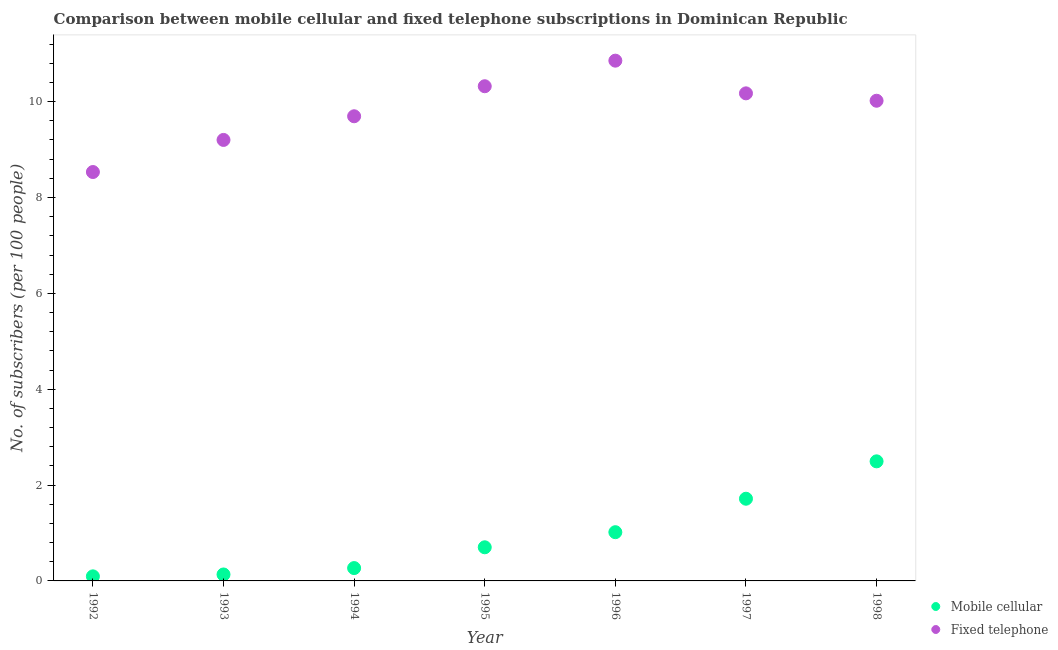Is the number of dotlines equal to the number of legend labels?
Your response must be concise. Yes. What is the number of mobile cellular subscribers in 1994?
Your answer should be very brief. 0.27. Across all years, what is the maximum number of fixed telephone subscribers?
Give a very brief answer. 10.85. Across all years, what is the minimum number of fixed telephone subscribers?
Offer a terse response. 8.53. What is the total number of fixed telephone subscribers in the graph?
Ensure brevity in your answer.  68.79. What is the difference between the number of mobile cellular subscribers in 1993 and that in 1996?
Ensure brevity in your answer.  -0.88. What is the difference between the number of mobile cellular subscribers in 1997 and the number of fixed telephone subscribers in 1994?
Provide a succinct answer. -7.98. What is the average number of fixed telephone subscribers per year?
Provide a short and direct response. 9.83. In the year 1996, what is the difference between the number of fixed telephone subscribers and number of mobile cellular subscribers?
Make the answer very short. 9.84. In how many years, is the number of fixed telephone subscribers greater than 7.6?
Make the answer very short. 7. What is the ratio of the number of mobile cellular subscribers in 1993 to that in 1994?
Your answer should be compact. 0.5. Is the difference between the number of fixed telephone subscribers in 1994 and 1995 greater than the difference between the number of mobile cellular subscribers in 1994 and 1995?
Your response must be concise. No. What is the difference between the highest and the second highest number of mobile cellular subscribers?
Provide a succinct answer. 0.78. What is the difference between the highest and the lowest number of mobile cellular subscribers?
Your answer should be very brief. 2.4. In how many years, is the number of mobile cellular subscribers greater than the average number of mobile cellular subscribers taken over all years?
Keep it short and to the point. 3. Is the sum of the number of fixed telephone subscribers in 1993 and 1997 greater than the maximum number of mobile cellular subscribers across all years?
Keep it short and to the point. Yes. Is the number of mobile cellular subscribers strictly less than the number of fixed telephone subscribers over the years?
Your answer should be very brief. Yes. How many dotlines are there?
Offer a very short reply. 2. How many years are there in the graph?
Your response must be concise. 7. What is the difference between two consecutive major ticks on the Y-axis?
Keep it short and to the point. 2. Are the values on the major ticks of Y-axis written in scientific E-notation?
Keep it short and to the point. No. Does the graph contain any zero values?
Offer a very short reply. No. Does the graph contain grids?
Ensure brevity in your answer.  No. What is the title of the graph?
Your response must be concise. Comparison between mobile cellular and fixed telephone subscriptions in Dominican Republic. Does "Domestic Liabilities" appear as one of the legend labels in the graph?
Give a very brief answer. No. What is the label or title of the X-axis?
Your answer should be compact. Year. What is the label or title of the Y-axis?
Offer a terse response. No. of subscribers (per 100 people). What is the No. of subscribers (per 100 people) in Mobile cellular in 1992?
Give a very brief answer. 0.1. What is the No. of subscribers (per 100 people) in Fixed telephone in 1992?
Your answer should be very brief. 8.53. What is the No. of subscribers (per 100 people) in Mobile cellular in 1993?
Offer a terse response. 0.13. What is the No. of subscribers (per 100 people) of Fixed telephone in 1993?
Offer a terse response. 9.2. What is the No. of subscribers (per 100 people) of Mobile cellular in 1994?
Offer a terse response. 0.27. What is the No. of subscribers (per 100 people) in Fixed telephone in 1994?
Your response must be concise. 9.69. What is the No. of subscribers (per 100 people) in Mobile cellular in 1995?
Your answer should be very brief. 0.7. What is the No. of subscribers (per 100 people) of Fixed telephone in 1995?
Give a very brief answer. 10.32. What is the No. of subscribers (per 100 people) of Mobile cellular in 1996?
Provide a succinct answer. 1.02. What is the No. of subscribers (per 100 people) of Fixed telephone in 1996?
Your response must be concise. 10.85. What is the No. of subscribers (per 100 people) in Mobile cellular in 1997?
Ensure brevity in your answer.  1.71. What is the No. of subscribers (per 100 people) in Fixed telephone in 1997?
Provide a succinct answer. 10.17. What is the No. of subscribers (per 100 people) in Mobile cellular in 1998?
Make the answer very short. 2.49. What is the No. of subscribers (per 100 people) of Fixed telephone in 1998?
Offer a very short reply. 10.02. Across all years, what is the maximum No. of subscribers (per 100 people) of Mobile cellular?
Keep it short and to the point. 2.49. Across all years, what is the maximum No. of subscribers (per 100 people) in Fixed telephone?
Provide a succinct answer. 10.85. Across all years, what is the minimum No. of subscribers (per 100 people) of Mobile cellular?
Your answer should be compact. 0.1. Across all years, what is the minimum No. of subscribers (per 100 people) in Fixed telephone?
Keep it short and to the point. 8.53. What is the total No. of subscribers (per 100 people) in Mobile cellular in the graph?
Your response must be concise. 6.43. What is the total No. of subscribers (per 100 people) in Fixed telephone in the graph?
Give a very brief answer. 68.79. What is the difference between the No. of subscribers (per 100 people) in Mobile cellular in 1992 and that in 1993?
Provide a short and direct response. -0.04. What is the difference between the No. of subscribers (per 100 people) of Fixed telephone in 1992 and that in 1993?
Your answer should be very brief. -0.67. What is the difference between the No. of subscribers (per 100 people) in Mobile cellular in 1992 and that in 1994?
Give a very brief answer. -0.17. What is the difference between the No. of subscribers (per 100 people) in Fixed telephone in 1992 and that in 1994?
Make the answer very short. -1.16. What is the difference between the No. of subscribers (per 100 people) of Mobile cellular in 1992 and that in 1995?
Give a very brief answer. -0.61. What is the difference between the No. of subscribers (per 100 people) in Fixed telephone in 1992 and that in 1995?
Provide a short and direct response. -1.79. What is the difference between the No. of subscribers (per 100 people) of Mobile cellular in 1992 and that in 1996?
Offer a very short reply. -0.92. What is the difference between the No. of subscribers (per 100 people) of Fixed telephone in 1992 and that in 1996?
Keep it short and to the point. -2.32. What is the difference between the No. of subscribers (per 100 people) in Mobile cellular in 1992 and that in 1997?
Provide a short and direct response. -1.62. What is the difference between the No. of subscribers (per 100 people) in Fixed telephone in 1992 and that in 1997?
Offer a very short reply. -1.64. What is the difference between the No. of subscribers (per 100 people) in Mobile cellular in 1992 and that in 1998?
Your response must be concise. -2.4. What is the difference between the No. of subscribers (per 100 people) of Fixed telephone in 1992 and that in 1998?
Make the answer very short. -1.49. What is the difference between the No. of subscribers (per 100 people) in Mobile cellular in 1993 and that in 1994?
Your response must be concise. -0.13. What is the difference between the No. of subscribers (per 100 people) of Fixed telephone in 1993 and that in 1994?
Give a very brief answer. -0.49. What is the difference between the No. of subscribers (per 100 people) of Mobile cellular in 1993 and that in 1995?
Provide a succinct answer. -0.57. What is the difference between the No. of subscribers (per 100 people) in Fixed telephone in 1993 and that in 1995?
Your response must be concise. -1.12. What is the difference between the No. of subscribers (per 100 people) of Mobile cellular in 1993 and that in 1996?
Ensure brevity in your answer.  -0.88. What is the difference between the No. of subscribers (per 100 people) in Fixed telephone in 1993 and that in 1996?
Give a very brief answer. -1.65. What is the difference between the No. of subscribers (per 100 people) of Mobile cellular in 1993 and that in 1997?
Your answer should be compact. -1.58. What is the difference between the No. of subscribers (per 100 people) of Fixed telephone in 1993 and that in 1997?
Make the answer very short. -0.97. What is the difference between the No. of subscribers (per 100 people) in Mobile cellular in 1993 and that in 1998?
Your response must be concise. -2.36. What is the difference between the No. of subscribers (per 100 people) of Fixed telephone in 1993 and that in 1998?
Ensure brevity in your answer.  -0.82. What is the difference between the No. of subscribers (per 100 people) in Mobile cellular in 1994 and that in 1995?
Provide a succinct answer. -0.43. What is the difference between the No. of subscribers (per 100 people) in Fixed telephone in 1994 and that in 1995?
Make the answer very short. -0.63. What is the difference between the No. of subscribers (per 100 people) in Mobile cellular in 1994 and that in 1996?
Your answer should be compact. -0.75. What is the difference between the No. of subscribers (per 100 people) of Fixed telephone in 1994 and that in 1996?
Offer a very short reply. -1.16. What is the difference between the No. of subscribers (per 100 people) in Mobile cellular in 1994 and that in 1997?
Your answer should be compact. -1.45. What is the difference between the No. of subscribers (per 100 people) in Fixed telephone in 1994 and that in 1997?
Provide a short and direct response. -0.48. What is the difference between the No. of subscribers (per 100 people) in Mobile cellular in 1994 and that in 1998?
Provide a short and direct response. -2.23. What is the difference between the No. of subscribers (per 100 people) of Fixed telephone in 1994 and that in 1998?
Provide a short and direct response. -0.32. What is the difference between the No. of subscribers (per 100 people) of Mobile cellular in 1995 and that in 1996?
Offer a terse response. -0.32. What is the difference between the No. of subscribers (per 100 people) of Fixed telephone in 1995 and that in 1996?
Keep it short and to the point. -0.53. What is the difference between the No. of subscribers (per 100 people) of Mobile cellular in 1995 and that in 1997?
Your answer should be very brief. -1.01. What is the difference between the No. of subscribers (per 100 people) of Fixed telephone in 1995 and that in 1997?
Ensure brevity in your answer.  0.15. What is the difference between the No. of subscribers (per 100 people) in Mobile cellular in 1995 and that in 1998?
Give a very brief answer. -1.79. What is the difference between the No. of subscribers (per 100 people) of Fixed telephone in 1995 and that in 1998?
Keep it short and to the point. 0.3. What is the difference between the No. of subscribers (per 100 people) in Mobile cellular in 1996 and that in 1997?
Offer a terse response. -0.7. What is the difference between the No. of subscribers (per 100 people) in Fixed telephone in 1996 and that in 1997?
Your response must be concise. 0.68. What is the difference between the No. of subscribers (per 100 people) in Mobile cellular in 1996 and that in 1998?
Your answer should be compact. -1.48. What is the difference between the No. of subscribers (per 100 people) in Fixed telephone in 1996 and that in 1998?
Your answer should be compact. 0.84. What is the difference between the No. of subscribers (per 100 people) in Mobile cellular in 1997 and that in 1998?
Your answer should be compact. -0.78. What is the difference between the No. of subscribers (per 100 people) of Fixed telephone in 1997 and that in 1998?
Offer a very short reply. 0.15. What is the difference between the No. of subscribers (per 100 people) in Mobile cellular in 1992 and the No. of subscribers (per 100 people) in Fixed telephone in 1993?
Provide a succinct answer. -9.11. What is the difference between the No. of subscribers (per 100 people) in Mobile cellular in 1992 and the No. of subscribers (per 100 people) in Fixed telephone in 1994?
Your response must be concise. -9.6. What is the difference between the No. of subscribers (per 100 people) in Mobile cellular in 1992 and the No. of subscribers (per 100 people) in Fixed telephone in 1995?
Provide a short and direct response. -10.23. What is the difference between the No. of subscribers (per 100 people) in Mobile cellular in 1992 and the No. of subscribers (per 100 people) in Fixed telephone in 1996?
Provide a short and direct response. -10.76. What is the difference between the No. of subscribers (per 100 people) of Mobile cellular in 1992 and the No. of subscribers (per 100 people) of Fixed telephone in 1997?
Keep it short and to the point. -10.08. What is the difference between the No. of subscribers (per 100 people) in Mobile cellular in 1992 and the No. of subscribers (per 100 people) in Fixed telephone in 1998?
Your response must be concise. -9.92. What is the difference between the No. of subscribers (per 100 people) of Mobile cellular in 1993 and the No. of subscribers (per 100 people) of Fixed telephone in 1994?
Offer a terse response. -9.56. What is the difference between the No. of subscribers (per 100 people) of Mobile cellular in 1993 and the No. of subscribers (per 100 people) of Fixed telephone in 1995?
Give a very brief answer. -10.19. What is the difference between the No. of subscribers (per 100 people) in Mobile cellular in 1993 and the No. of subscribers (per 100 people) in Fixed telephone in 1996?
Your response must be concise. -10.72. What is the difference between the No. of subscribers (per 100 people) of Mobile cellular in 1993 and the No. of subscribers (per 100 people) of Fixed telephone in 1997?
Provide a short and direct response. -10.04. What is the difference between the No. of subscribers (per 100 people) in Mobile cellular in 1993 and the No. of subscribers (per 100 people) in Fixed telephone in 1998?
Provide a succinct answer. -9.88. What is the difference between the No. of subscribers (per 100 people) of Mobile cellular in 1994 and the No. of subscribers (per 100 people) of Fixed telephone in 1995?
Give a very brief answer. -10.05. What is the difference between the No. of subscribers (per 100 people) in Mobile cellular in 1994 and the No. of subscribers (per 100 people) in Fixed telephone in 1996?
Your answer should be compact. -10.59. What is the difference between the No. of subscribers (per 100 people) in Mobile cellular in 1994 and the No. of subscribers (per 100 people) in Fixed telephone in 1997?
Your answer should be compact. -9.9. What is the difference between the No. of subscribers (per 100 people) of Mobile cellular in 1994 and the No. of subscribers (per 100 people) of Fixed telephone in 1998?
Keep it short and to the point. -9.75. What is the difference between the No. of subscribers (per 100 people) of Mobile cellular in 1995 and the No. of subscribers (per 100 people) of Fixed telephone in 1996?
Your response must be concise. -10.15. What is the difference between the No. of subscribers (per 100 people) of Mobile cellular in 1995 and the No. of subscribers (per 100 people) of Fixed telephone in 1997?
Ensure brevity in your answer.  -9.47. What is the difference between the No. of subscribers (per 100 people) of Mobile cellular in 1995 and the No. of subscribers (per 100 people) of Fixed telephone in 1998?
Ensure brevity in your answer.  -9.32. What is the difference between the No. of subscribers (per 100 people) of Mobile cellular in 1996 and the No. of subscribers (per 100 people) of Fixed telephone in 1997?
Offer a very short reply. -9.16. What is the difference between the No. of subscribers (per 100 people) in Mobile cellular in 1996 and the No. of subscribers (per 100 people) in Fixed telephone in 1998?
Provide a short and direct response. -9. What is the difference between the No. of subscribers (per 100 people) of Mobile cellular in 1997 and the No. of subscribers (per 100 people) of Fixed telephone in 1998?
Offer a very short reply. -8.3. What is the average No. of subscribers (per 100 people) of Mobile cellular per year?
Your response must be concise. 0.92. What is the average No. of subscribers (per 100 people) of Fixed telephone per year?
Offer a very short reply. 9.83. In the year 1992, what is the difference between the No. of subscribers (per 100 people) of Mobile cellular and No. of subscribers (per 100 people) of Fixed telephone?
Provide a short and direct response. -8.44. In the year 1993, what is the difference between the No. of subscribers (per 100 people) of Mobile cellular and No. of subscribers (per 100 people) of Fixed telephone?
Ensure brevity in your answer.  -9.07. In the year 1994, what is the difference between the No. of subscribers (per 100 people) in Mobile cellular and No. of subscribers (per 100 people) in Fixed telephone?
Provide a short and direct response. -9.43. In the year 1995, what is the difference between the No. of subscribers (per 100 people) in Mobile cellular and No. of subscribers (per 100 people) in Fixed telephone?
Offer a very short reply. -9.62. In the year 1996, what is the difference between the No. of subscribers (per 100 people) in Mobile cellular and No. of subscribers (per 100 people) in Fixed telephone?
Ensure brevity in your answer.  -9.84. In the year 1997, what is the difference between the No. of subscribers (per 100 people) in Mobile cellular and No. of subscribers (per 100 people) in Fixed telephone?
Provide a succinct answer. -8.46. In the year 1998, what is the difference between the No. of subscribers (per 100 people) in Mobile cellular and No. of subscribers (per 100 people) in Fixed telephone?
Provide a short and direct response. -7.52. What is the ratio of the No. of subscribers (per 100 people) of Mobile cellular in 1992 to that in 1993?
Provide a succinct answer. 0.71. What is the ratio of the No. of subscribers (per 100 people) in Fixed telephone in 1992 to that in 1993?
Make the answer very short. 0.93. What is the ratio of the No. of subscribers (per 100 people) of Mobile cellular in 1992 to that in 1994?
Provide a short and direct response. 0.36. What is the ratio of the No. of subscribers (per 100 people) in Mobile cellular in 1992 to that in 1995?
Provide a succinct answer. 0.14. What is the ratio of the No. of subscribers (per 100 people) in Fixed telephone in 1992 to that in 1995?
Keep it short and to the point. 0.83. What is the ratio of the No. of subscribers (per 100 people) of Mobile cellular in 1992 to that in 1996?
Your answer should be very brief. 0.09. What is the ratio of the No. of subscribers (per 100 people) in Fixed telephone in 1992 to that in 1996?
Your answer should be very brief. 0.79. What is the ratio of the No. of subscribers (per 100 people) in Mobile cellular in 1992 to that in 1997?
Your answer should be very brief. 0.06. What is the ratio of the No. of subscribers (per 100 people) of Fixed telephone in 1992 to that in 1997?
Keep it short and to the point. 0.84. What is the ratio of the No. of subscribers (per 100 people) of Mobile cellular in 1992 to that in 1998?
Provide a succinct answer. 0.04. What is the ratio of the No. of subscribers (per 100 people) in Fixed telephone in 1992 to that in 1998?
Your answer should be compact. 0.85. What is the ratio of the No. of subscribers (per 100 people) in Mobile cellular in 1993 to that in 1994?
Provide a short and direct response. 0.5. What is the ratio of the No. of subscribers (per 100 people) of Fixed telephone in 1993 to that in 1994?
Provide a short and direct response. 0.95. What is the ratio of the No. of subscribers (per 100 people) of Mobile cellular in 1993 to that in 1995?
Keep it short and to the point. 0.19. What is the ratio of the No. of subscribers (per 100 people) of Fixed telephone in 1993 to that in 1995?
Offer a terse response. 0.89. What is the ratio of the No. of subscribers (per 100 people) in Mobile cellular in 1993 to that in 1996?
Give a very brief answer. 0.13. What is the ratio of the No. of subscribers (per 100 people) of Fixed telephone in 1993 to that in 1996?
Your response must be concise. 0.85. What is the ratio of the No. of subscribers (per 100 people) of Mobile cellular in 1993 to that in 1997?
Provide a short and direct response. 0.08. What is the ratio of the No. of subscribers (per 100 people) in Fixed telephone in 1993 to that in 1997?
Your answer should be very brief. 0.9. What is the ratio of the No. of subscribers (per 100 people) in Mobile cellular in 1993 to that in 1998?
Offer a very short reply. 0.05. What is the ratio of the No. of subscribers (per 100 people) in Fixed telephone in 1993 to that in 1998?
Offer a terse response. 0.92. What is the ratio of the No. of subscribers (per 100 people) of Mobile cellular in 1994 to that in 1995?
Ensure brevity in your answer.  0.38. What is the ratio of the No. of subscribers (per 100 people) in Fixed telephone in 1994 to that in 1995?
Offer a very short reply. 0.94. What is the ratio of the No. of subscribers (per 100 people) in Mobile cellular in 1994 to that in 1996?
Give a very brief answer. 0.26. What is the ratio of the No. of subscribers (per 100 people) in Fixed telephone in 1994 to that in 1996?
Your answer should be very brief. 0.89. What is the ratio of the No. of subscribers (per 100 people) of Mobile cellular in 1994 to that in 1997?
Offer a very short reply. 0.16. What is the ratio of the No. of subscribers (per 100 people) of Fixed telephone in 1994 to that in 1997?
Provide a succinct answer. 0.95. What is the ratio of the No. of subscribers (per 100 people) of Mobile cellular in 1994 to that in 1998?
Give a very brief answer. 0.11. What is the ratio of the No. of subscribers (per 100 people) in Mobile cellular in 1995 to that in 1996?
Provide a short and direct response. 0.69. What is the ratio of the No. of subscribers (per 100 people) in Fixed telephone in 1995 to that in 1996?
Keep it short and to the point. 0.95. What is the ratio of the No. of subscribers (per 100 people) of Mobile cellular in 1995 to that in 1997?
Provide a short and direct response. 0.41. What is the ratio of the No. of subscribers (per 100 people) of Fixed telephone in 1995 to that in 1997?
Give a very brief answer. 1.01. What is the ratio of the No. of subscribers (per 100 people) of Mobile cellular in 1995 to that in 1998?
Your answer should be very brief. 0.28. What is the ratio of the No. of subscribers (per 100 people) of Fixed telephone in 1995 to that in 1998?
Keep it short and to the point. 1.03. What is the ratio of the No. of subscribers (per 100 people) in Mobile cellular in 1996 to that in 1997?
Make the answer very short. 0.59. What is the ratio of the No. of subscribers (per 100 people) in Fixed telephone in 1996 to that in 1997?
Ensure brevity in your answer.  1.07. What is the ratio of the No. of subscribers (per 100 people) of Mobile cellular in 1996 to that in 1998?
Provide a short and direct response. 0.41. What is the ratio of the No. of subscribers (per 100 people) in Fixed telephone in 1996 to that in 1998?
Ensure brevity in your answer.  1.08. What is the ratio of the No. of subscribers (per 100 people) in Mobile cellular in 1997 to that in 1998?
Offer a terse response. 0.69. What is the ratio of the No. of subscribers (per 100 people) in Fixed telephone in 1997 to that in 1998?
Provide a succinct answer. 1.02. What is the difference between the highest and the second highest No. of subscribers (per 100 people) of Mobile cellular?
Provide a succinct answer. 0.78. What is the difference between the highest and the second highest No. of subscribers (per 100 people) of Fixed telephone?
Keep it short and to the point. 0.53. What is the difference between the highest and the lowest No. of subscribers (per 100 people) of Mobile cellular?
Offer a very short reply. 2.4. What is the difference between the highest and the lowest No. of subscribers (per 100 people) in Fixed telephone?
Your response must be concise. 2.32. 